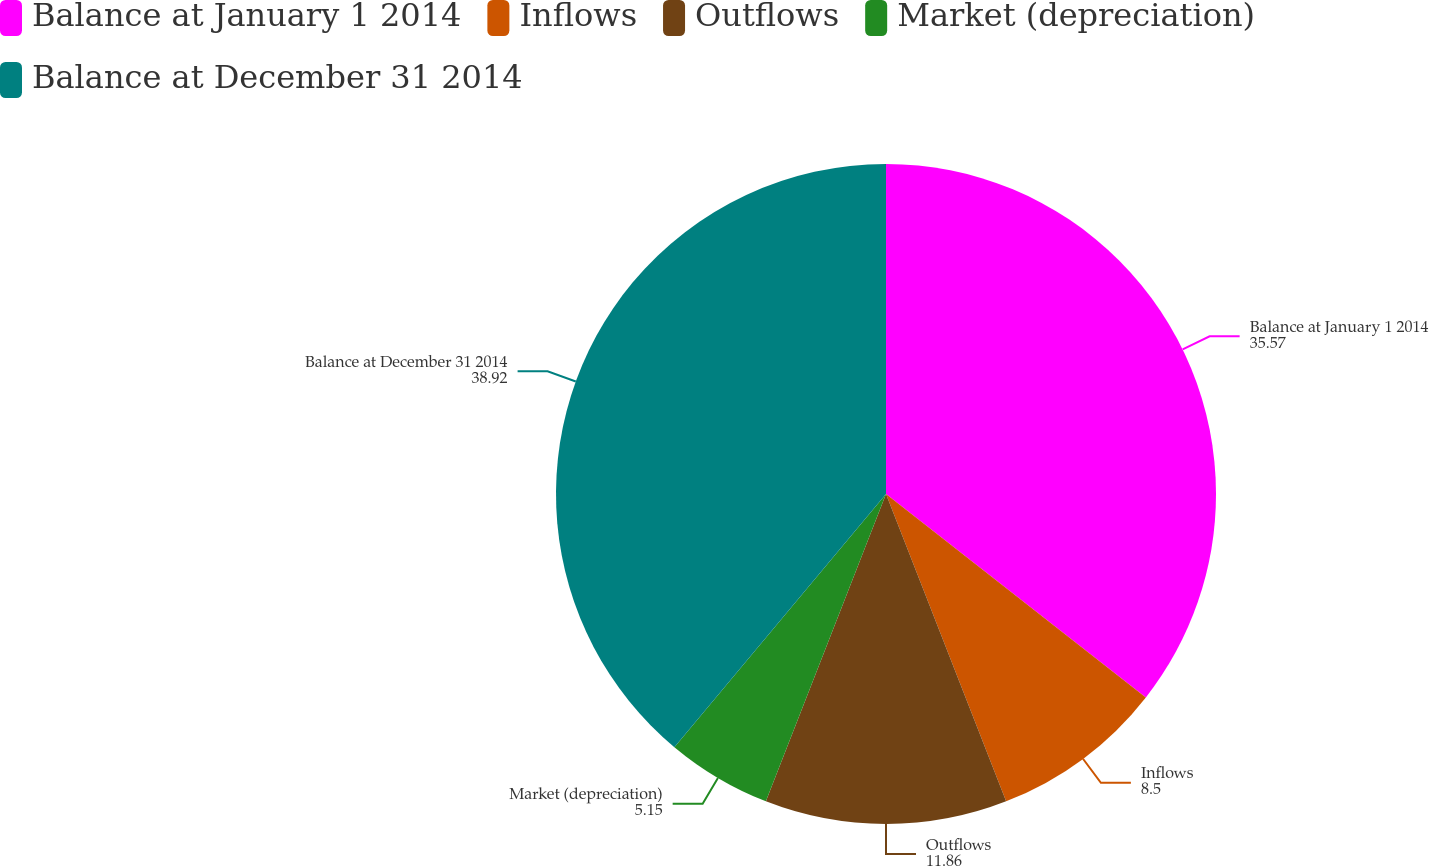Convert chart to OTSL. <chart><loc_0><loc_0><loc_500><loc_500><pie_chart><fcel>Balance at January 1 2014<fcel>Inflows<fcel>Outflows<fcel>Market (depreciation)<fcel>Balance at December 31 2014<nl><fcel>35.57%<fcel>8.5%<fcel>11.86%<fcel>5.15%<fcel>38.92%<nl></chart> 